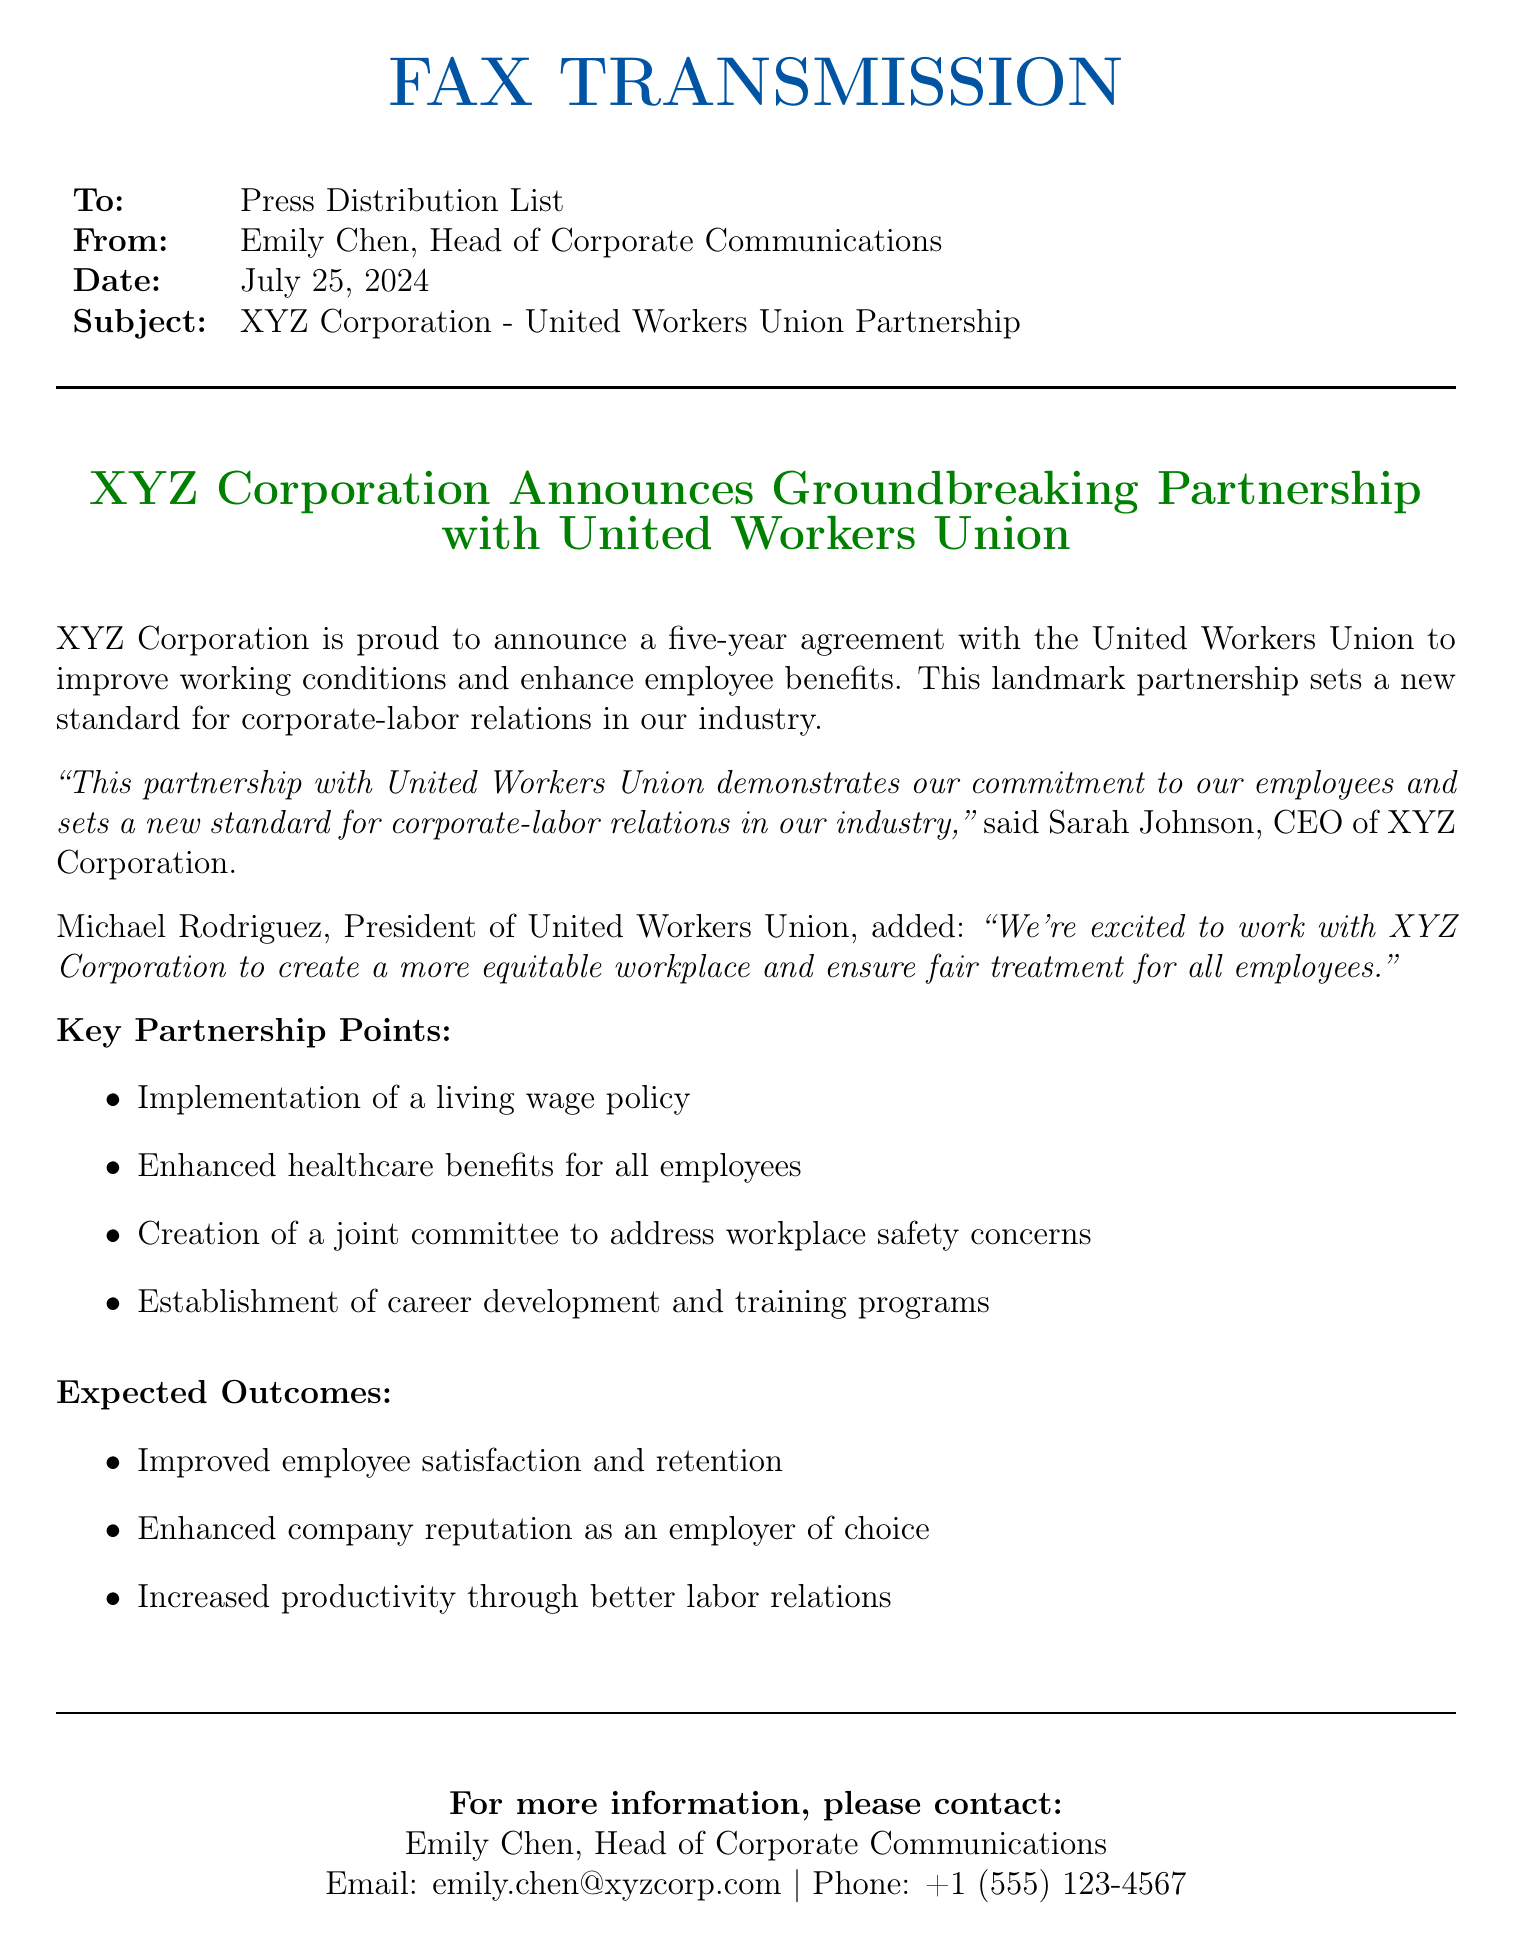What is the name of the union involved? The union involved in the partnership is explicitly mentioned in the document as the United Workers Union.
Answer: United Workers Union Who is the Head of Corporate Communications? The document states that Emily Chen holds this position, which is relevant for contact purposes.
Answer: Emily Chen What is the duration of the partnership agreement? It specifies a five-year agreement, outlining the timeframe of the partnership.
Answer: Five years What is one of the key partnership points mentioned? The document lists several key points, one of which is the implementation of a living wage policy.
Answer: Implementation of a living wage policy How many expected outcomes are listed? Counting the listed expected outcomes in the document, there are three items mentioned.
Answer: Three What title does Sarah Johnson hold? Sarah Johnson's title is mentioned in the document, showing her leadership role in the company.
Answer: CEO What is a potential benefit of the partnership for the company? The document states enhancing company reputation as an employer of choice as one of the outcomes.
Answer: Enhanced company reputation as an employer of choice Who is the President of the United Workers Union? The name of the President is provided in the document, establishing the leadership of the union.
Answer: Michael Rodriguez What type of document is this? The structure and context indicate that this is a fax transmission regarding a corporate announcement.
Answer: Fax transmission 